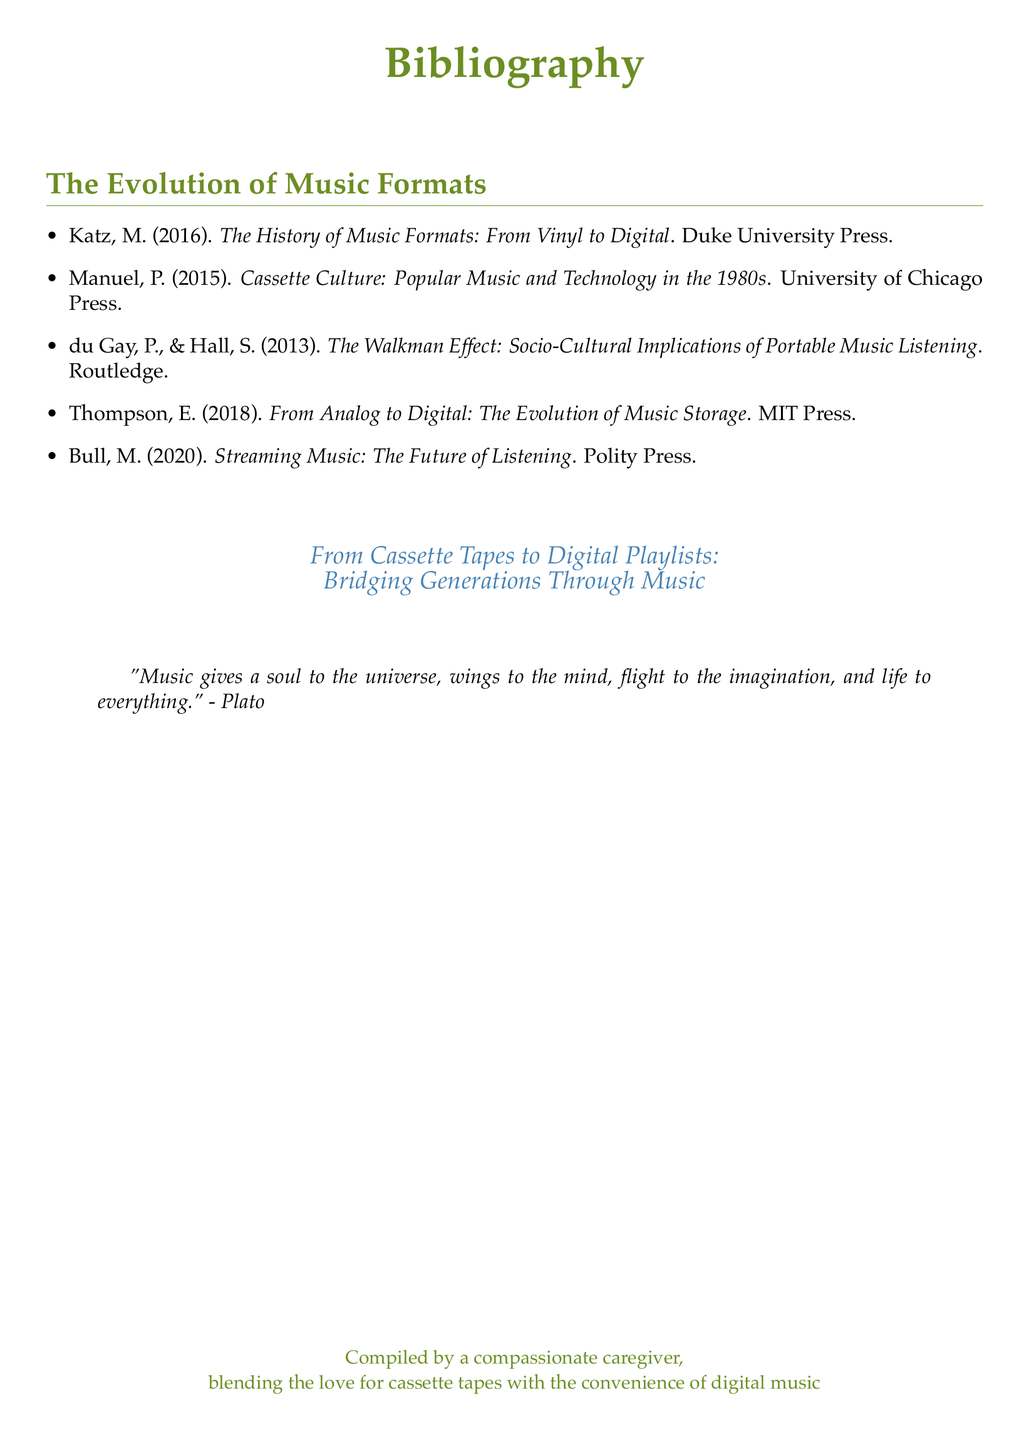What is the title of the document? The title of the document is presented prominently at the top, indicating its main topic.
Answer: Bibliography How many items are listed in the bibliography? The total number of entries can be counted from the list in the document.
Answer: 5 Who is the author of "Cassette Culture: Popular Music and Technology in the 1980s"? The author's name can be found next to the title of the book in the bibliography section.
Answer: P. Manuel What year was "Streaming Music: The Future of Listening" published? The publication year is specified next to the title of the book in the list.
Answer: 2020 Which press published "The History of Music Formats: From Vinyl to Digital"? The name of the publisher is listed after the title and the author's name.
Answer: Duke University Press What is the color theme used for the main title and section headings? The colors used for the title and section headings can be observed in the document.
Answer: Cassette green Which quote is included in the document? The quote is presented in italics within a quotation block in the document.
Answer: "Music gives a soul to the universe, wings to the mind, flight to the imagination, and life to everything." - Plato What is the focus of "From Cassette Tapes to Digital Playlists"? The focus is summarized in the subtitle of the document.
Answer: Bridging Generations Through Music Who compiled the document? The compiler's identity is mentioned at the bottom of the document.
Answer: A compassionate caregiver 